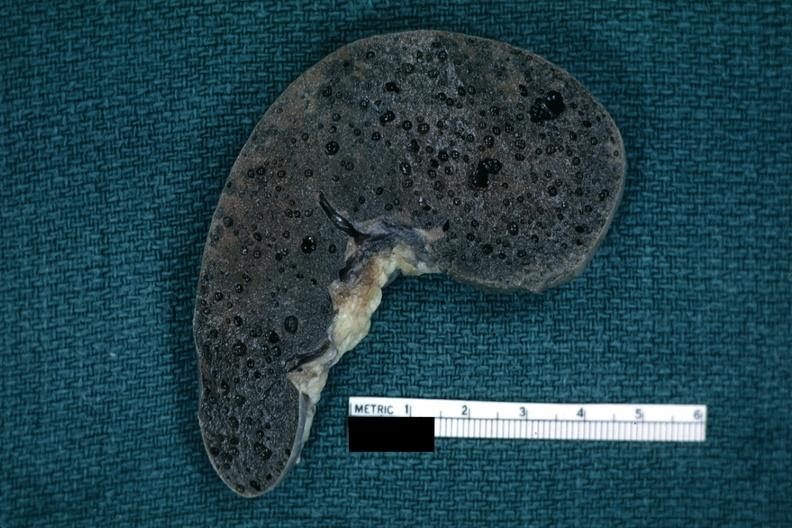where is this part in?
Answer the question using a single word or phrase. Spleen 